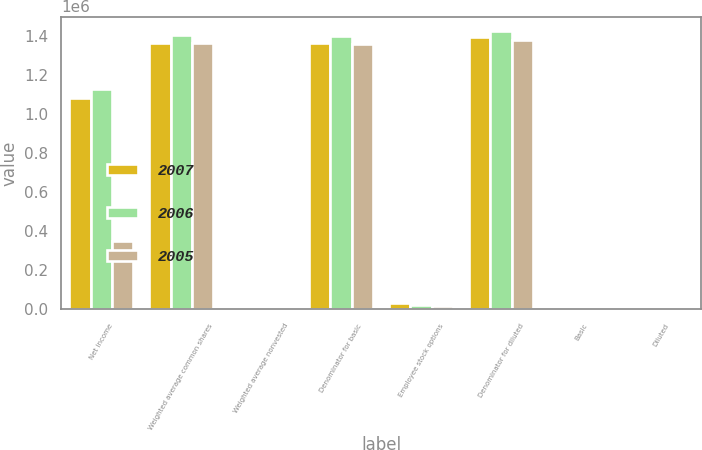Convert chart to OTSL. <chart><loc_0><loc_0><loc_500><loc_500><stacked_bar_chart><ecel><fcel>Net income<fcel>Weighted average common shares<fcel>Weighted average nonvested<fcel>Denominator for basic<fcel>Employee stock options<fcel>Denominator for diluted<fcel>Basic<fcel>Diluted<nl><fcel>2007<fcel>1.08204e+06<fcel>1.36175e+06<fcel>40<fcel>1.36171e+06<fcel>32127<fcel>1.39388e+06<fcel>0.79<fcel>0.78<nl><fcel>2006<fcel>1.12564e+06<fcel>1.40346e+06<fcel>4204<fcel>1.39925e+06<fcel>22017<fcel>1.42547e+06<fcel>0.8<fcel>0.79<nl><fcel>2005<fcel>348251<fcel>1.35928e+06<fcel>485<fcel>1.3588e+06<fcel>16892<fcel>1.37617e+06<fcel>0.26<fcel>0.25<nl></chart> 